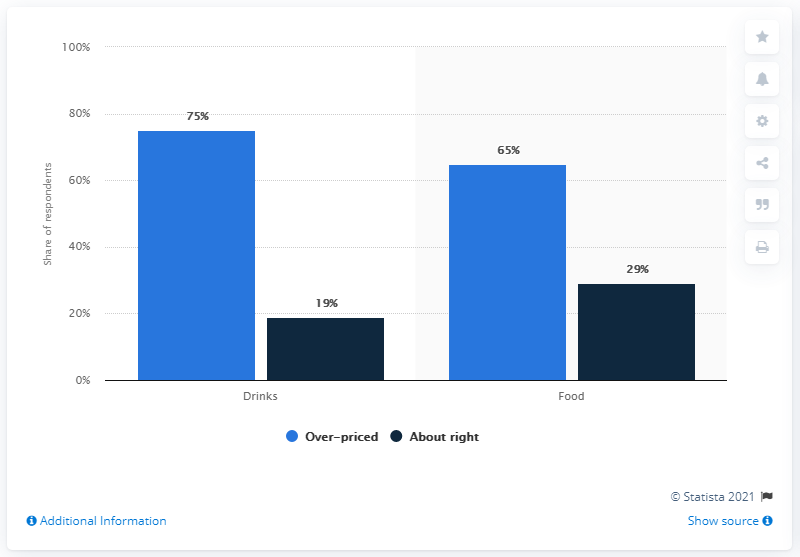List a handful of essential elements in this visual. The color with the smallest value is navy blue. The average over-priced opinion is more than that of an "about right" opinion across all items, with a difference of 46%. 